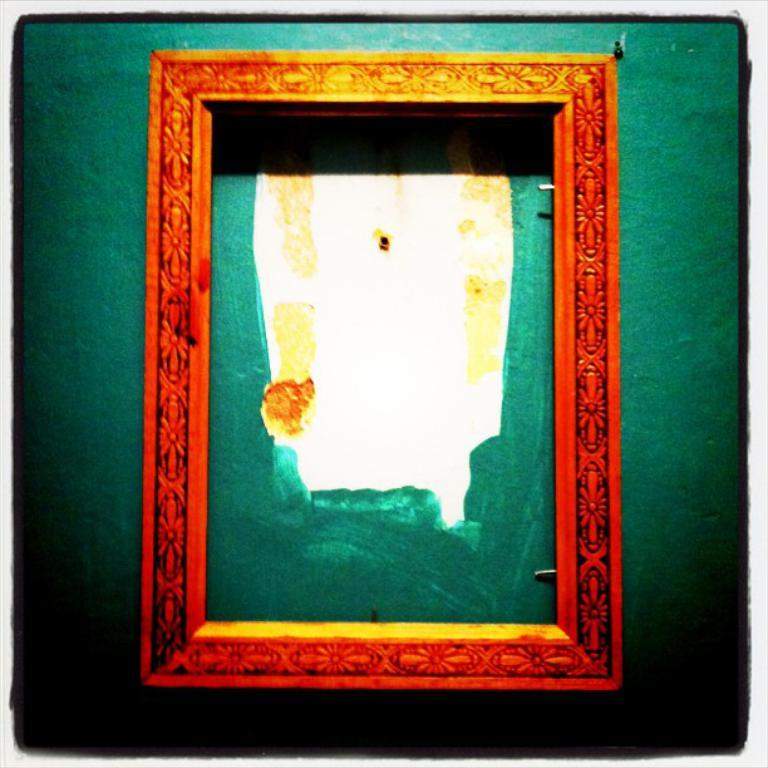What is the color of the frame in the image? The frame in the image is red. How is the frame positioned in the image? The frame is attached to the wall. How many ants can be seen crawling on the frame in the image? There are no ants present in the image; it only features a red color frame attached to the wall. 